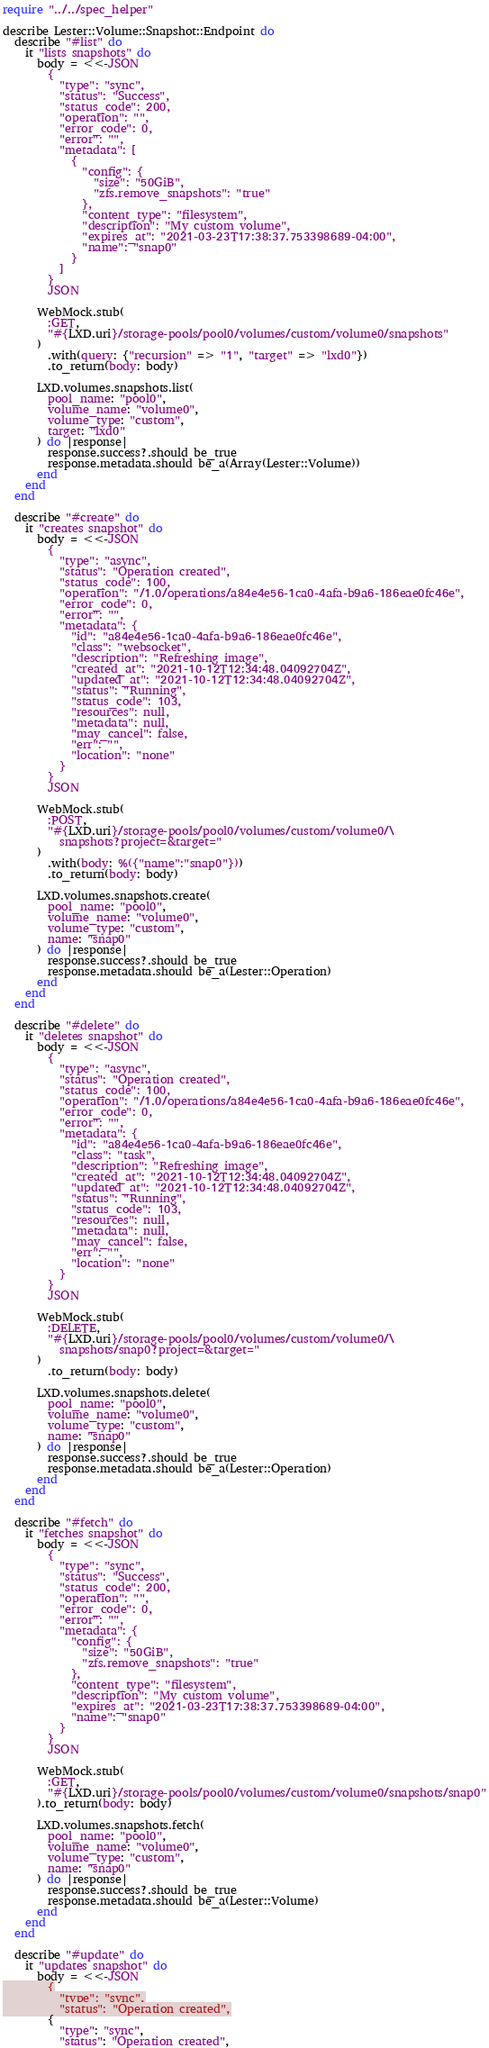<code> <loc_0><loc_0><loc_500><loc_500><_Crystal_>require "../../spec_helper"

describe Lester::Volume::Snapshot::Endpoint do
  describe "#list" do
    it "lists snapshots" do
      body = <<-JSON
        {
          "type": "sync",
          "status": "Success",
          "status_code": 200,
          "operation": "",
          "error_code": 0,
          "error": "",
          "metadata": [
            {
              "config": {
                "size": "50GiB",
                "zfs.remove_snapshots": "true"
              },
              "content_type": "filesystem",
              "description": "My custom volume",
              "expires_at": "2021-03-23T17:38:37.753398689-04:00",
              "name": "snap0"
            }
          ]
        }
        JSON

      WebMock.stub(
        :GET,
        "#{LXD.uri}/storage-pools/pool0/volumes/custom/volume0/snapshots"
      )
        .with(query: {"recursion" => "1", "target" => "lxd0"})
        .to_return(body: body)

      LXD.volumes.snapshots.list(
        pool_name: "pool0",
        volume_name: "volume0",
        volume_type: "custom",
        target: "lxd0"
      ) do |response|
        response.success?.should be_true
        response.metadata.should be_a(Array(Lester::Volume))
      end
    end
  end

  describe "#create" do
    it "creates snapshot" do
      body = <<-JSON
        {
          "type": "async",
          "status": "Operation created",
          "status_code": 100,
          "operation": "/1.0/operations/a84e4e56-1ca0-4afa-b9a6-186eae0fc46e",
          "error_code": 0,
          "error": "",
          "metadata": {
            "id": "a84e4e56-1ca0-4afa-b9a6-186eae0fc46e",
            "class": "websocket",
            "description": "Refreshing image",
            "created_at": "2021-10-12T12:34:48.04092704Z",
            "updated_at": "2021-10-12T12:34:48.04092704Z",
            "status": "Running",
            "status_code": 103,
            "resources": null,
            "metadata": null,
            "may_cancel": false,
            "err": "",
            "location": "none"
          }
        }
        JSON

      WebMock.stub(
        :POST,
        "#{LXD.uri}/storage-pools/pool0/volumes/custom/volume0/\
          snapshots?project=&target="
      )
        .with(body: %({"name":"snap0"}))
        .to_return(body: body)

      LXD.volumes.snapshots.create(
        pool_name: "pool0",
        volume_name: "volume0",
        volume_type: "custom",
        name: "snap0"
      ) do |response|
        response.success?.should be_true
        response.metadata.should be_a(Lester::Operation)
      end
    end
  end

  describe "#delete" do
    it "deletes snapshot" do
      body = <<-JSON
        {
          "type": "async",
          "status": "Operation created",
          "status_code": 100,
          "operation": "/1.0/operations/a84e4e56-1ca0-4afa-b9a6-186eae0fc46e",
          "error_code": 0,
          "error": "",
          "metadata": {
            "id": "a84e4e56-1ca0-4afa-b9a6-186eae0fc46e",
            "class": "task",
            "description": "Refreshing image",
            "created_at": "2021-10-12T12:34:48.04092704Z",
            "updated_at": "2021-10-12T12:34:48.04092704Z",
            "status": "Running",
            "status_code": 103,
            "resources": null,
            "metadata": null,
            "may_cancel": false,
            "err": "",
            "location": "none"
          }
        }
        JSON

      WebMock.stub(
        :DELETE,
        "#{LXD.uri}/storage-pools/pool0/volumes/custom/volume0/\
          snapshots/snap0?project=&target="
      )
        .to_return(body: body)

      LXD.volumes.snapshots.delete(
        pool_name: "pool0",
        volume_name: "volume0",
        volume_type: "custom",
        name: "snap0"
      ) do |response|
        response.success?.should be_true
        response.metadata.should be_a(Lester::Operation)
      end
    end
  end

  describe "#fetch" do
    it "fetches snapshot" do
      body = <<-JSON
        {
          "type": "sync",
          "status": "Success",
          "status_code": 200,
          "operation": "",
          "error_code": 0,
          "error": "",
          "metadata": {
            "config": {
              "size": "50GiB",
              "zfs.remove_snapshots": "true"
            },
            "content_type": "filesystem",
            "description": "My custom volume",
            "expires_at": "2021-03-23T17:38:37.753398689-04:00",
            "name": "snap0"
          }
        }
        JSON

      WebMock.stub(
        :GET,
        "#{LXD.uri}/storage-pools/pool0/volumes/custom/volume0/snapshots/snap0"
      ).to_return(body: body)

      LXD.volumes.snapshots.fetch(
        pool_name: "pool0",
        volume_name: "volume0",
        volume_type: "custom",
        name: "snap0"
      ) do |response|
        response.success?.should be_true
        response.metadata.should be_a(Lester::Volume)
      end
    end
  end

  describe "#update" do
    it "updates snapshot" do
      body = <<-JSON
        {
          "type": "sync",
          "status": "Operation created",</code> 